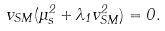Convert formula to latex. <formula><loc_0><loc_0><loc_500><loc_500>v _ { S M } ( \mu ^ { 2 } _ { s } + \lambda _ { 1 } v _ { S M } ^ { 2 } ) = 0 .</formula> 